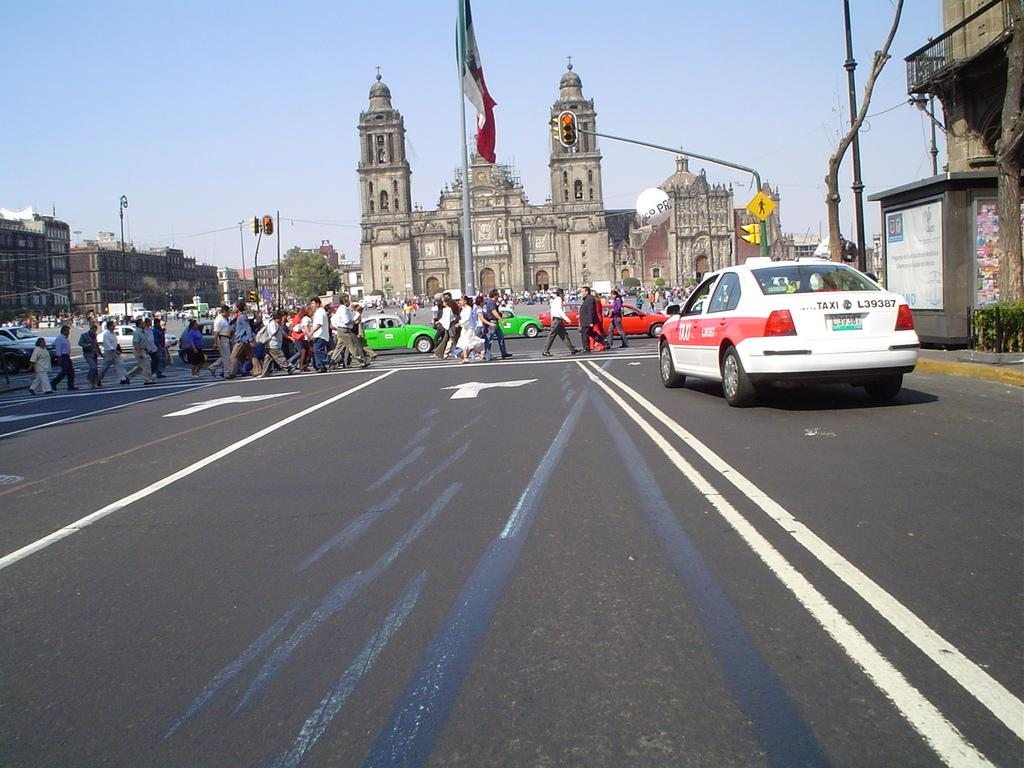<image>
Provide a brief description of the given image. Taxi number L39387 waits at a busy crosswalk. 